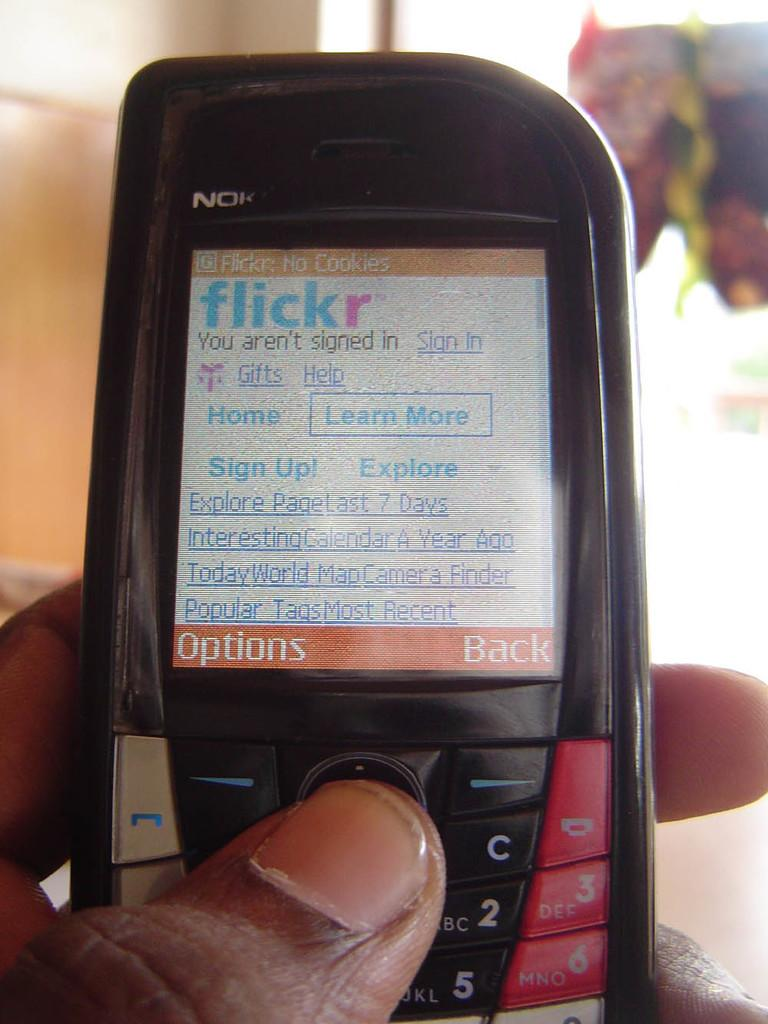What is the person holding in the image? There is a person's hand holding a mobile in the image. What can be seen on the mobile screen? Something is written on the mobile screen. Can you describe the background of the image? The background of the image is blurred. What type of doctor is standing next to the person in the image? There is no doctor present in the image; it only shows a person's hand holding a mobile with a blurred background. 